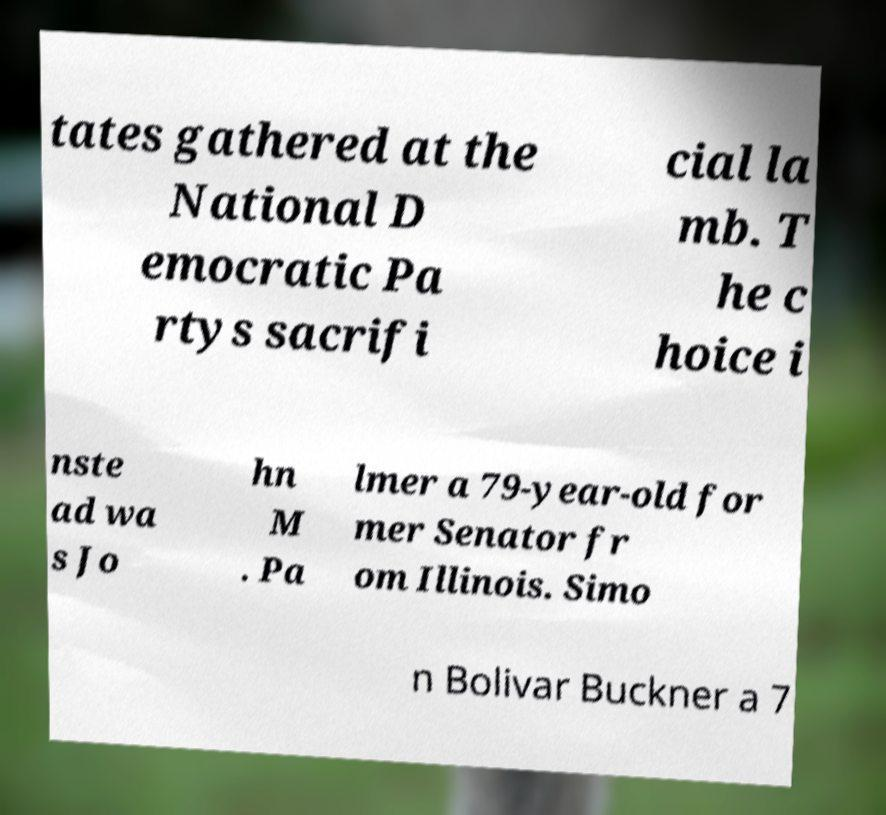Could you assist in decoding the text presented in this image and type it out clearly? tates gathered at the National D emocratic Pa rtys sacrifi cial la mb. T he c hoice i nste ad wa s Jo hn M . Pa lmer a 79-year-old for mer Senator fr om Illinois. Simo n Bolivar Buckner a 7 